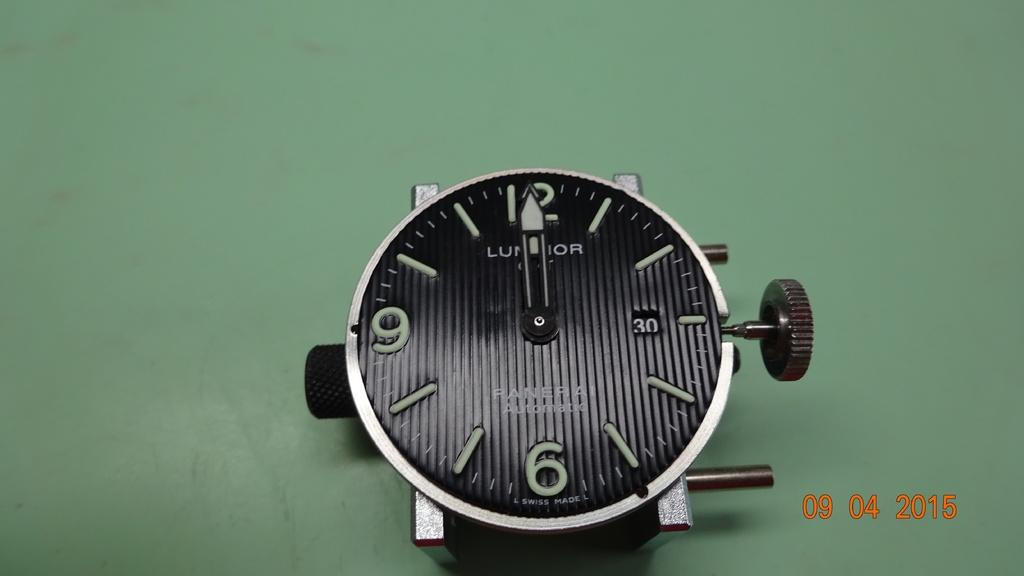<image>
Write a terse but informative summary of the picture. A black PANERAI watch face that is Swiss Made. 